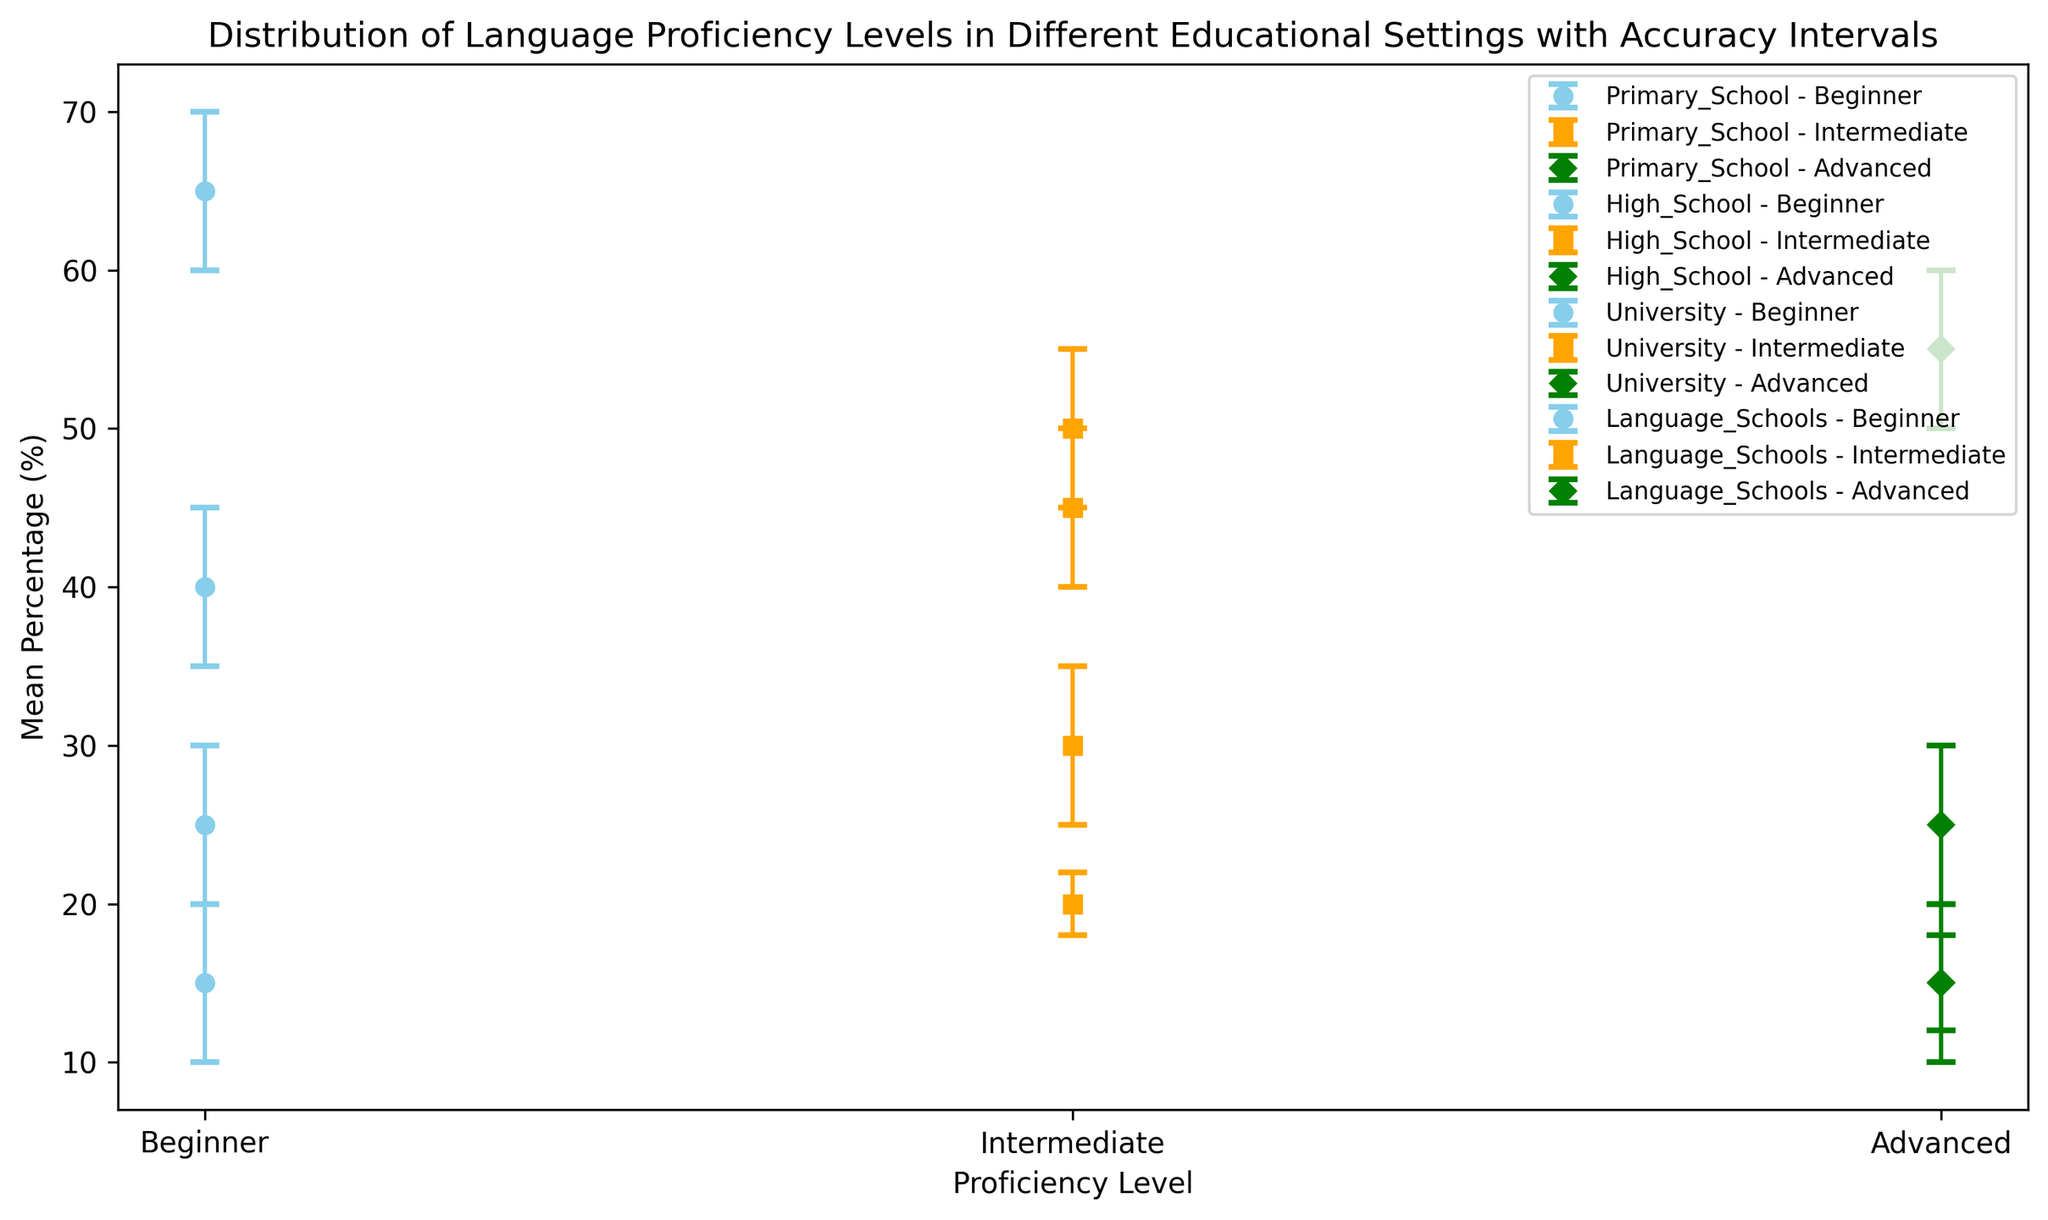what is the difference in the mean percentage of the beginner proficiency level between primary school and high school? To find the difference, look at the mean percentage of the beginner proficiency level in Primary School (65%) and High School (40%). Subtract the mean percentage of High School from Primary School: 65% - 40% = 25%.
Answer: 25% Which educational setting has the highest mean percentage for the advanced proficiency level? By examining the errorbars for the advanced proficiency level, the highest mean percentage is in Language Schools at 55%.
Answer: Language Schools Which educational setting has the smallest error bar for the intermediate proficiency level? The smallest error bar means the smallest range between the lower and upper interval. For the intermediate level: Primary School (2%), High School (5%), University (5%), Language Schools (5%). The primary school has the smallest error bar of 4%.
Answer: Primary School How does the mean percentage of the advanced proficiency level in universities compare to that in primary schools? The mean percentage for the advanced level is 25% in universities and 15% in primary schools. Since 25% is greater than 15%, it shows that universities have a higher mean percentage.
Answer: Universities have a higher mean percentage What is the mean percentage range (lower to upper interval) for intermediate proficiency in high school, and how does it compare to the range in language schools? The intermediate proficiency range for high school is from 40% to 50%, and for language schools is from 25% to 35%. Comparing ranges, both ranges span 10%, although their actual sizes are equal.
Answer: Both ranges span 10% Which proficiency level in primary school has the widest accuracy interval? The accuracy interval ranges can be found by subtracting the lower interval from the upper interval for each proficiency level. For Primary School: Beginner (10%), Intermediate (4%), Advanced (6%). The widest interval is for the beginner level at 10%.
Answer: Beginner What is the difference in the upper interval value of the intermediate proficiency level between high school and university? To find the difference, look at the upper interval value for the intermediate proficiency level: High School (50%) and University (55%). Subtract the high school value from the university value: 55% - 50% = 5%.
Answer: 5% What proportion of total advanced proficiency falls within the lower interval range for universities and language schools combined? Considering the range for universities (20%) and Language Schools (50%), the combined proportion is 20% + 50% = 70%.
Answer: 70% Among all the educational settings, which has the lowest mean percentage for the beginner proficiency level? The lowest mean percentage for beginner proficiency is observed in Language Schools at 15%.
Answer: Language Schools Which educational setting has the most balanced distribution of proficiency levels (mean percentages are closest to each other)? By evaluating the mean percentages, High School seems to have the most balanced distribution: Beginner (40%), Intermediate (45%), Advanced (15%).
Answer: High School 